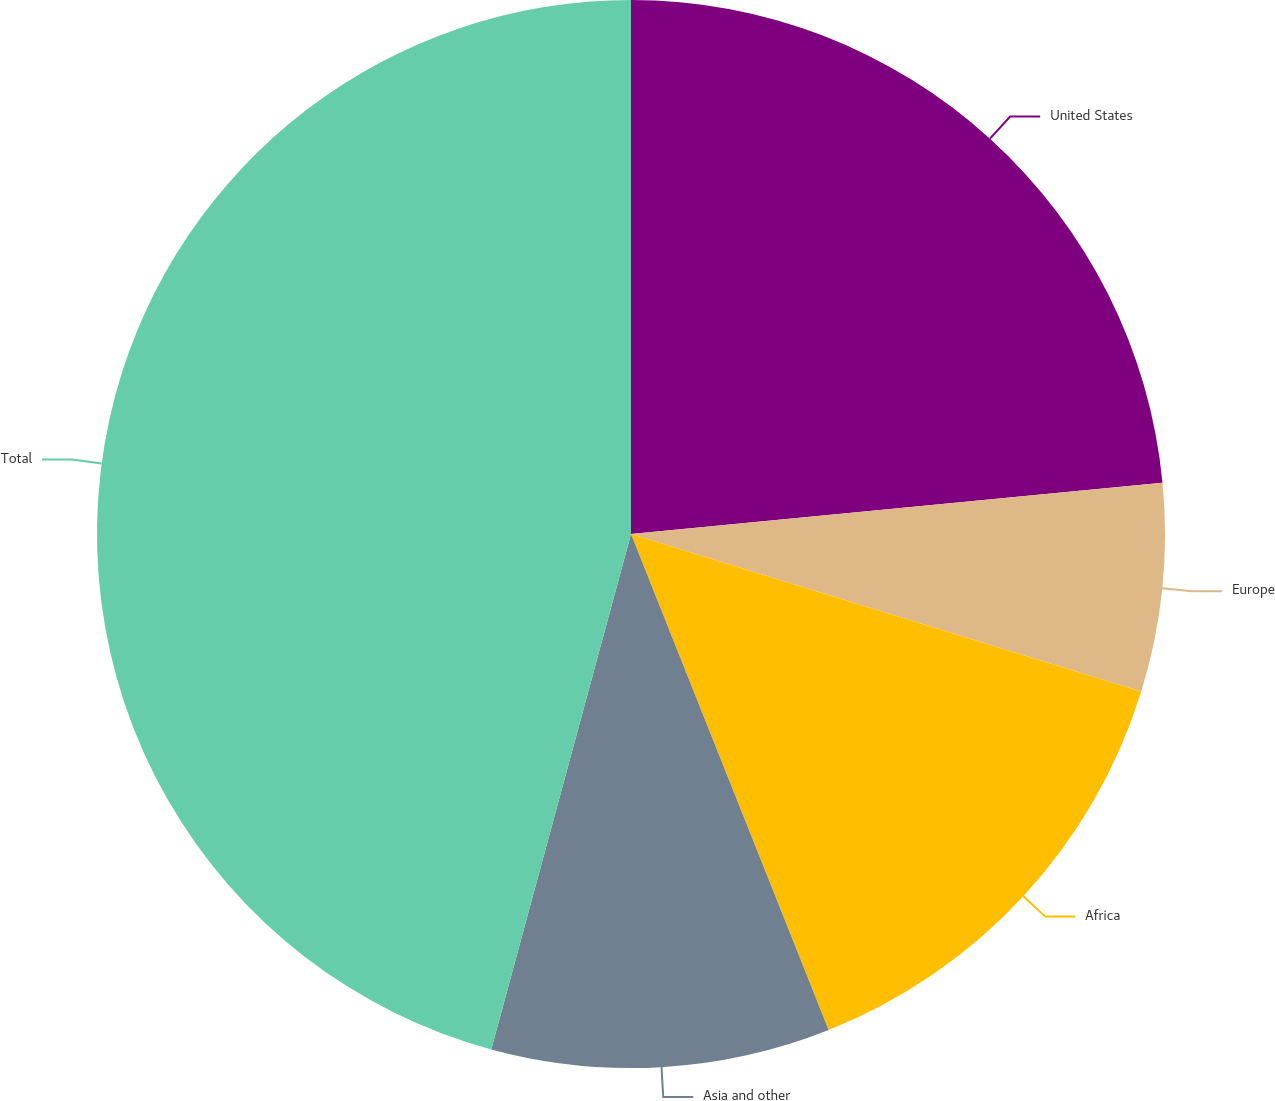<chart> <loc_0><loc_0><loc_500><loc_500><pie_chart><fcel>United States<fcel>Europe<fcel>Africa<fcel>Asia and other<fcel>Total<nl><fcel>23.47%<fcel>6.3%<fcel>14.2%<fcel>10.25%<fcel>45.79%<nl></chart> 